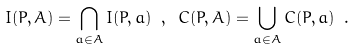Convert formula to latex. <formula><loc_0><loc_0><loc_500><loc_500>I ( P , A ) = \bigcap _ { a \in A } I ( P , a ) \ , \ C ( P , A ) = \bigcup _ { a \in A } C ( P , a ) \ .</formula> 